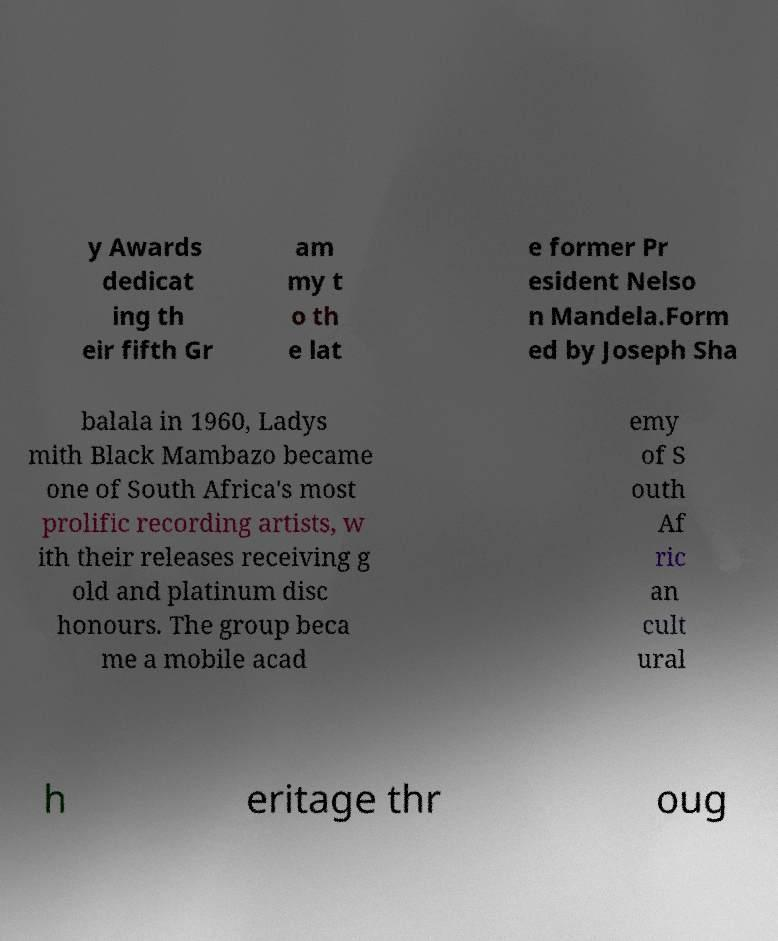Can you read and provide the text displayed in the image?This photo seems to have some interesting text. Can you extract and type it out for me? y Awards dedicat ing th eir fifth Gr am my t o th e lat e former Pr esident Nelso n Mandela.Form ed by Joseph Sha balala in 1960, Ladys mith Black Mambazo became one of South Africa's most prolific recording artists, w ith their releases receiving g old and platinum disc honours. The group beca me a mobile acad emy of S outh Af ric an cult ural h eritage thr oug 